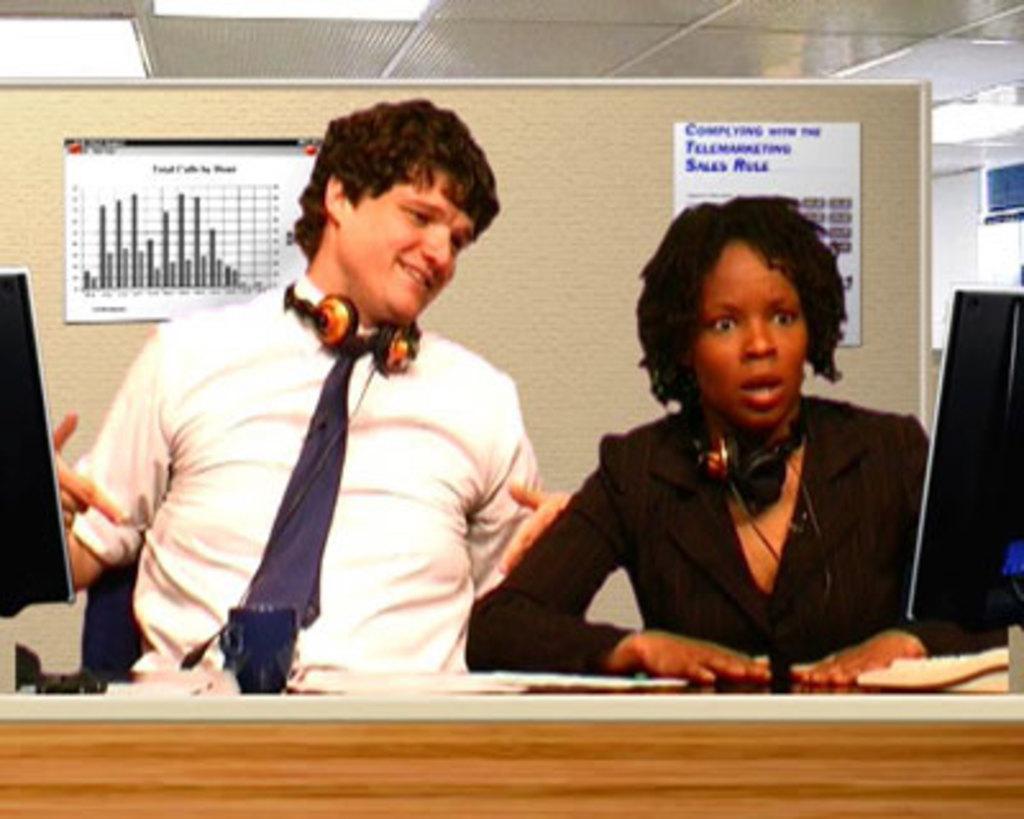How would you summarize this image in a sentence or two? This image is taken indoors. At the bottom of the image there is a table with a few things on it. In the background there is a board with a few posters with text on them. At the top of the image there is a ceiling with lights. In the middle of the image a man and a woman are sitting on the chairs. 